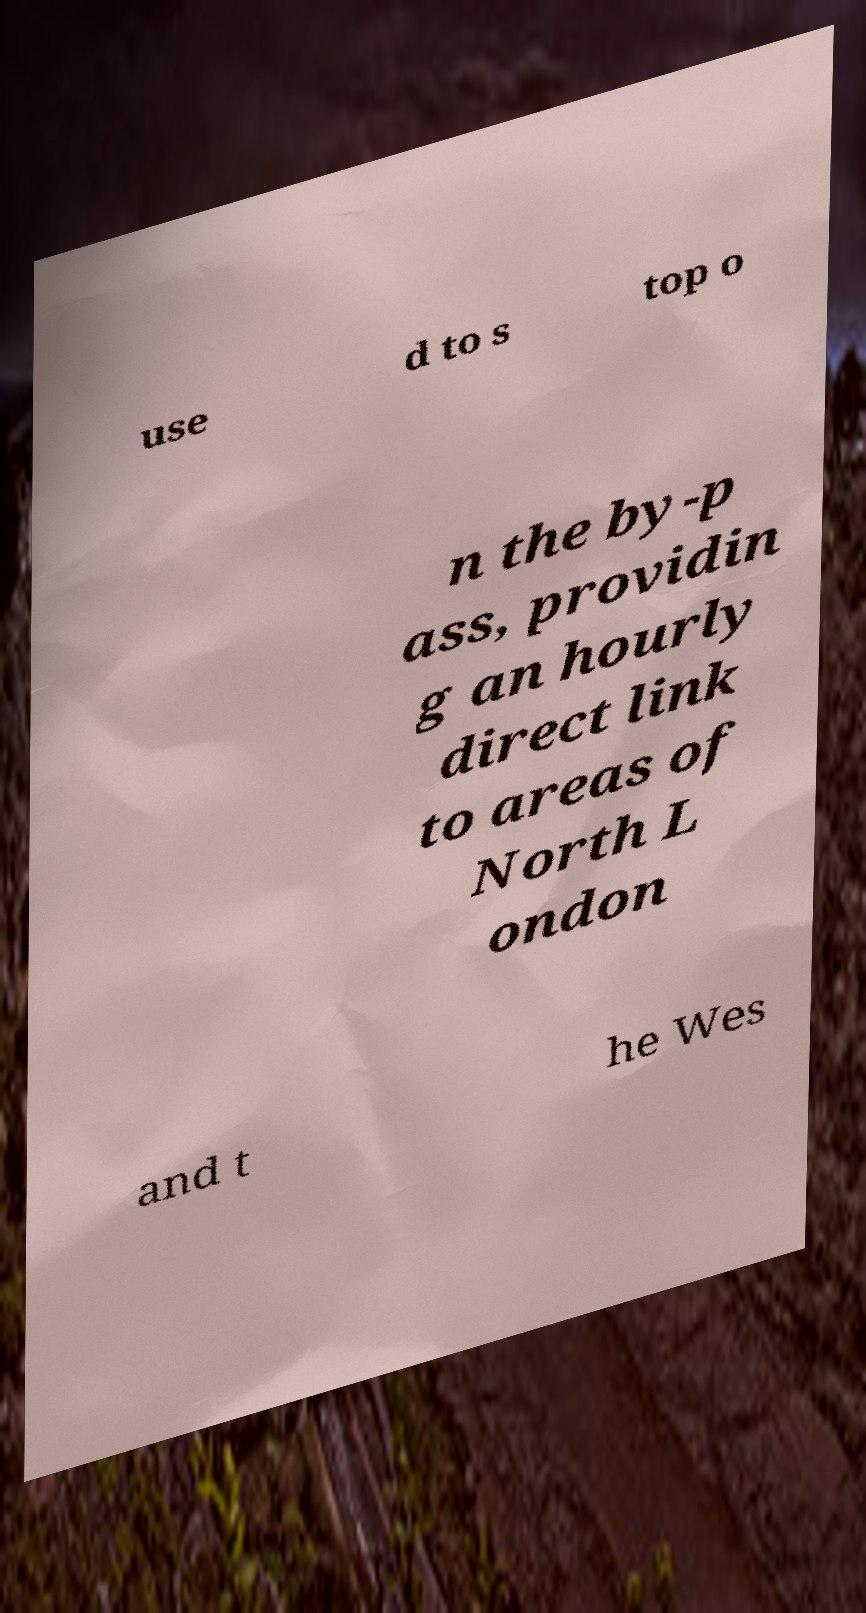Please read and relay the text visible in this image. What does it say? use d to s top o n the by-p ass, providin g an hourly direct link to areas of North L ondon and t he Wes 